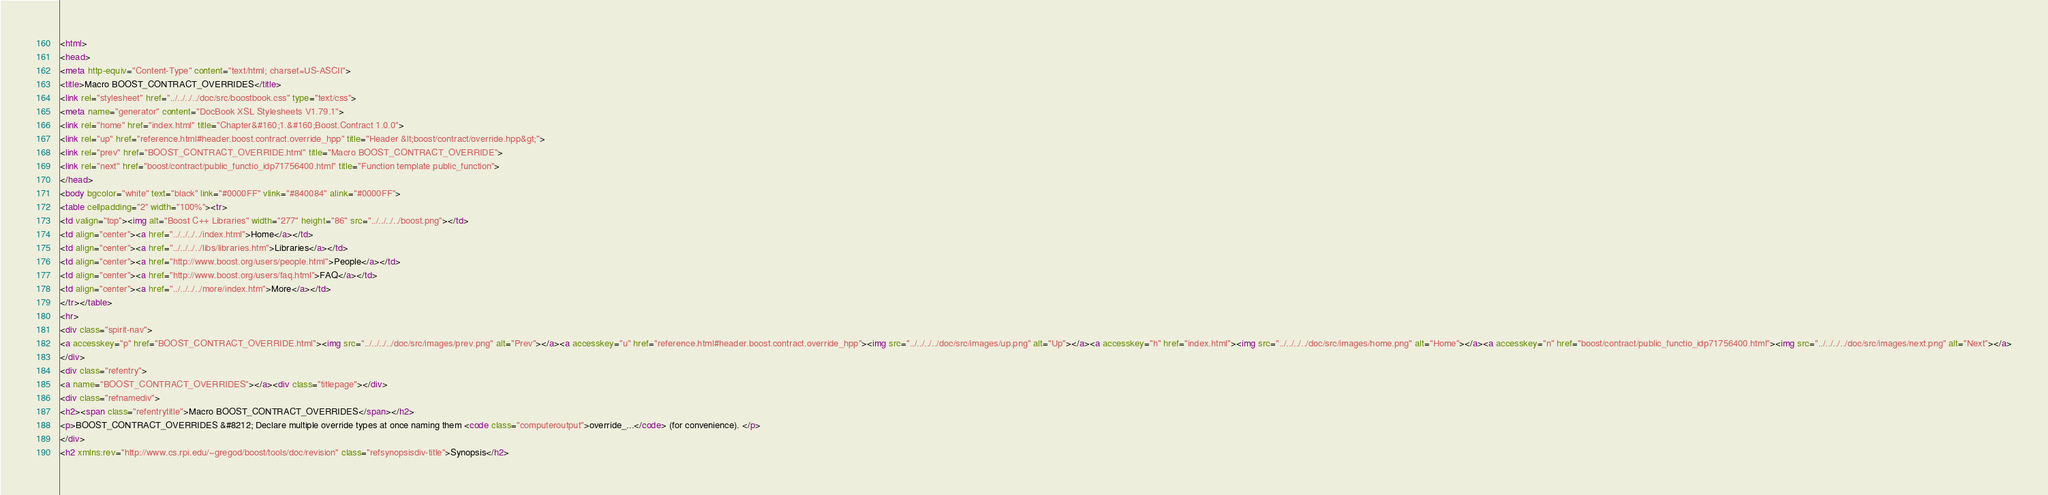<code> <loc_0><loc_0><loc_500><loc_500><_HTML_><html>
<head>
<meta http-equiv="Content-Type" content="text/html; charset=US-ASCII">
<title>Macro BOOST_CONTRACT_OVERRIDES</title>
<link rel="stylesheet" href="../../../../doc/src/boostbook.css" type="text/css">
<meta name="generator" content="DocBook XSL Stylesheets V1.79.1">
<link rel="home" href="index.html" title="Chapter&#160;1.&#160;Boost.Contract 1.0.0">
<link rel="up" href="reference.html#header.boost.contract.override_hpp" title="Header &lt;boost/contract/override.hpp&gt;">
<link rel="prev" href="BOOST_CONTRACT_OVERRIDE.html" title="Macro BOOST_CONTRACT_OVERRIDE">
<link rel="next" href="boost/contract/public_functio_idp71756400.html" title="Function template public_function">
</head>
<body bgcolor="white" text="black" link="#0000FF" vlink="#840084" alink="#0000FF">
<table cellpadding="2" width="100%"><tr>
<td valign="top"><img alt="Boost C++ Libraries" width="277" height="86" src="../../../../boost.png"></td>
<td align="center"><a href="../../../../index.html">Home</a></td>
<td align="center"><a href="../../../../libs/libraries.htm">Libraries</a></td>
<td align="center"><a href="http://www.boost.org/users/people.html">People</a></td>
<td align="center"><a href="http://www.boost.org/users/faq.html">FAQ</a></td>
<td align="center"><a href="../../../../more/index.htm">More</a></td>
</tr></table>
<hr>
<div class="spirit-nav">
<a accesskey="p" href="BOOST_CONTRACT_OVERRIDE.html"><img src="../../../../doc/src/images/prev.png" alt="Prev"></a><a accesskey="u" href="reference.html#header.boost.contract.override_hpp"><img src="../../../../doc/src/images/up.png" alt="Up"></a><a accesskey="h" href="index.html"><img src="../../../../doc/src/images/home.png" alt="Home"></a><a accesskey="n" href="boost/contract/public_functio_idp71756400.html"><img src="../../../../doc/src/images/next.png" alt="Next"></a>
</div>
<div class="refentry">
<a name="BOOST_CONTRACT_OVERRIDES"></a><div class="titlepage"></div>
<div class="refnamediv">
<h2><span class="refentrytitle">Macro BOOST_CONTRACT_OVERRIDES</span></h2>
<p>BOOST_CONTRACT_OVERRIDES &#8212; Declare multiple override types at once naming them <code class="computeroutput">override_...</code> (for convenience). </p>
</div>
<h2 xmlns:rev="http://www.cs.rpi.edu/~gregod/boost/tools/doc/revision" class="refsynopsisdiv-title">Synopsis</h2></code> 